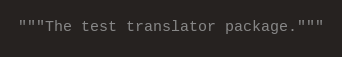<code> <loc_0><loc_0><loc_500><loc_500><_Python_>"""The test translator package."""
</code> 